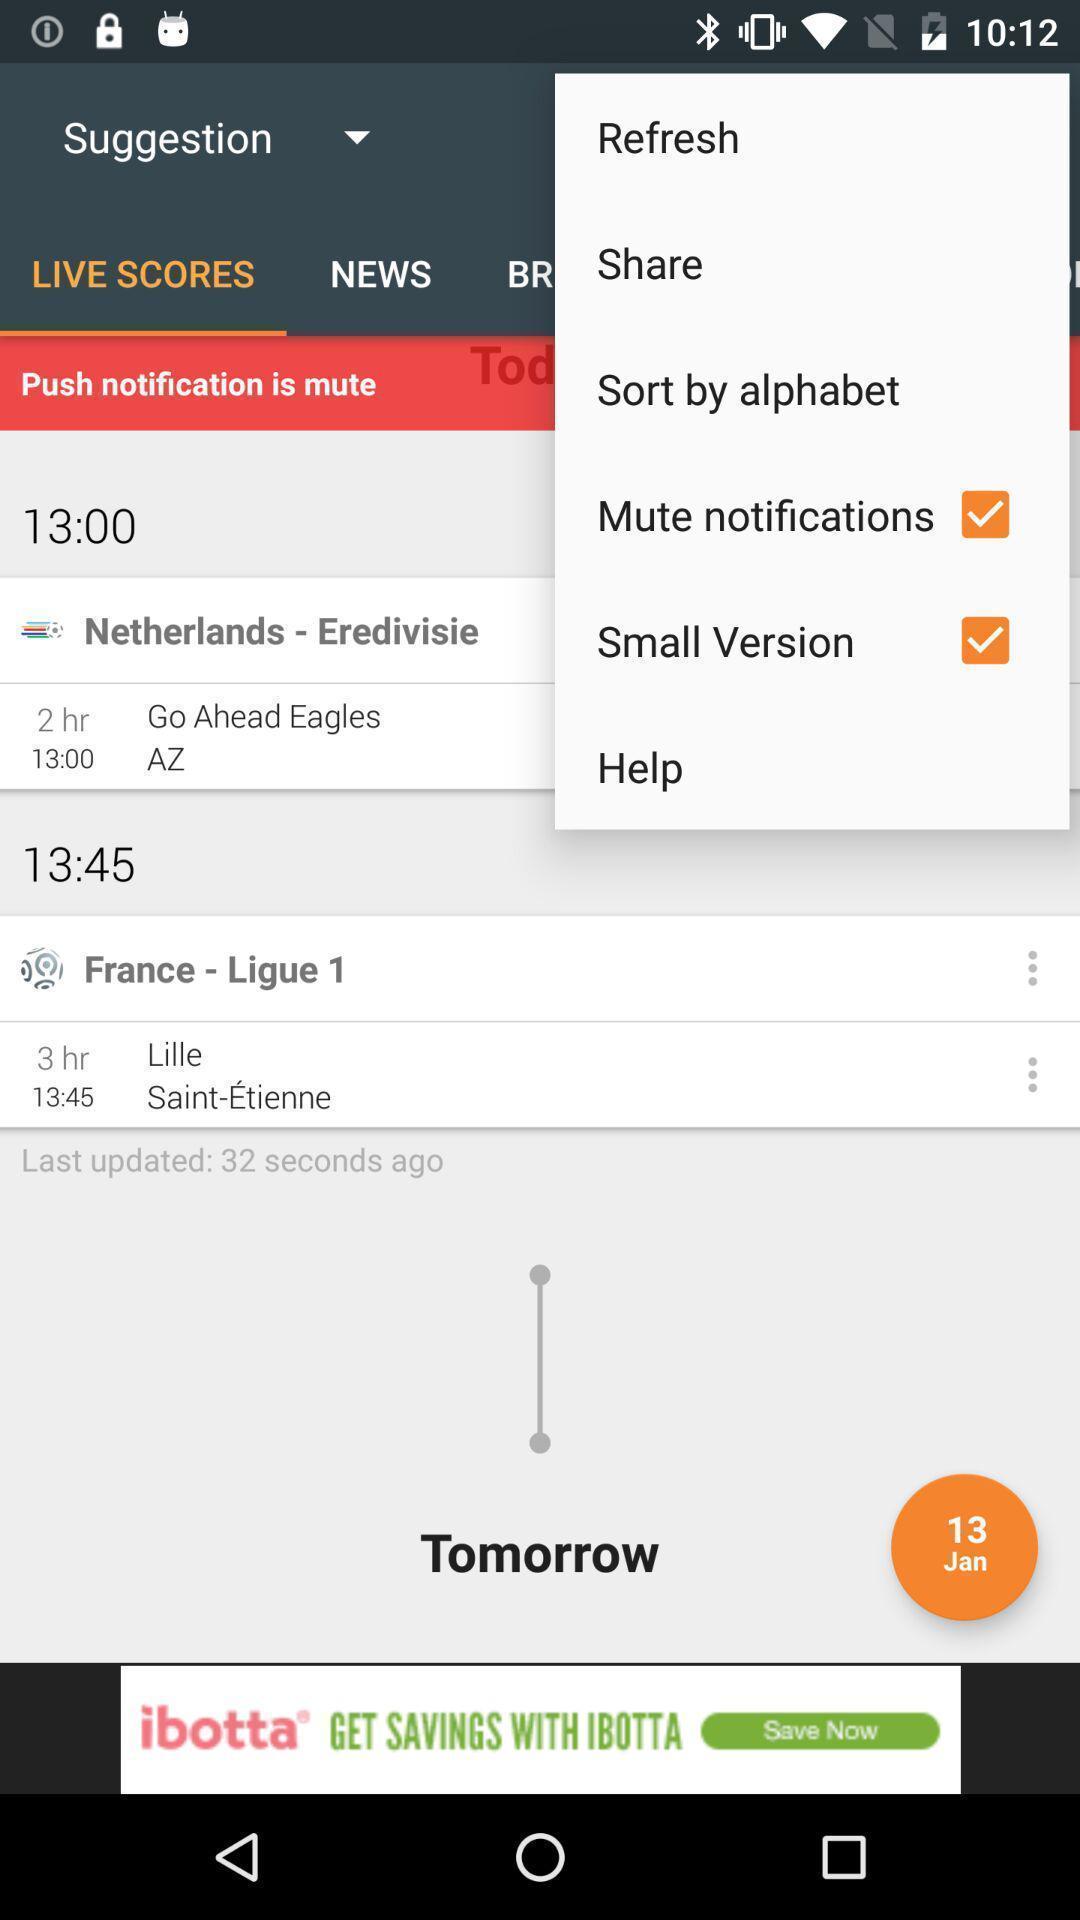Describe the visual elements of this screenshot. Popup showing of different options. 